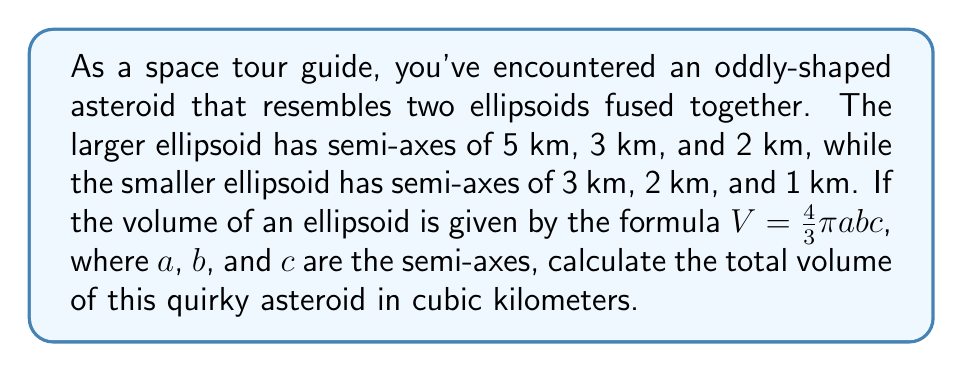Show me your answer to this math problem. Let's approach this step-by-step:

1) First, we need to calculate the volume of each ellipsoid separately.

2) For the larger ellipsoid:
   $a_1 = 5$ km, $b_1 = 3$ km, $c_1 = 2$ km
   $$V_1 = \frac{4}{3}\pi a_1b_1c_1 = \frac{4}{3}\pi(5)(3)(2) = \frac{40}{3}\pi$$

3) For the smaller ellipsoid:
   $a_2 = 3$ km, $b_2 = 2$ km, $c_2 = 1$ km
   $$V_2 = \frac{4}{3}\pi a_2b_2c_2 = \frac{4}{3}\pi(3)(2)(1) = 8\pi$$

4) The total volume is the sum of these two volumes:
   $$V_{total} = V_1 + V_2 = \frac{40}{3}\pi + 8\pi = \frac{40}{3}\pi + \frac{24}{3}\pi = \frac{64}{3}\pi$$

5) Simplifying:
   $$V_{total} = \frac{64}{3}\pi \approx 67.02$$ cubic kilometers
Answer: $\frac{64}{3}\pi$ cubic kilometers 